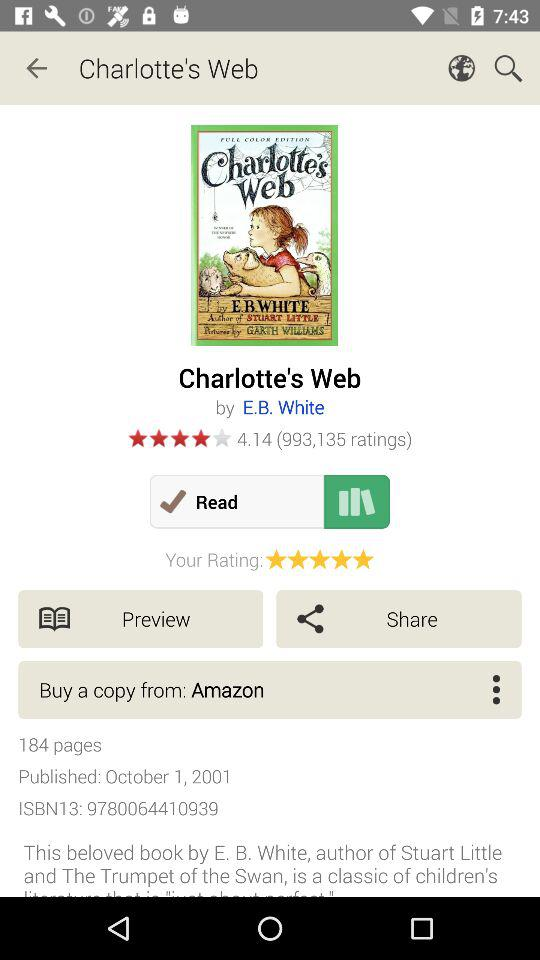What is the title of the book? The title of the book is "Charlotte's Web". 